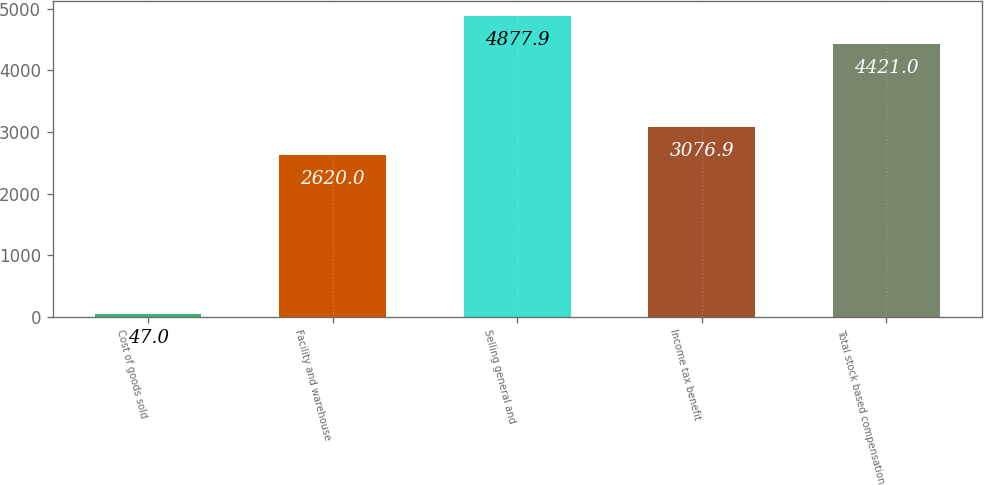<chart> <loc_0><loc_0><loc_500><loc_500><bar_chart><fcel>Cost of goods sold<fcel>Facility and warehouse<fcel>Selling general and<fcel>Income tax benefit<fcel>Total stock based compensation<nl><fcel>47<fcel>2620<fcel>4877.9<fcel>3076.9<fcel>4421<nl></chart> 